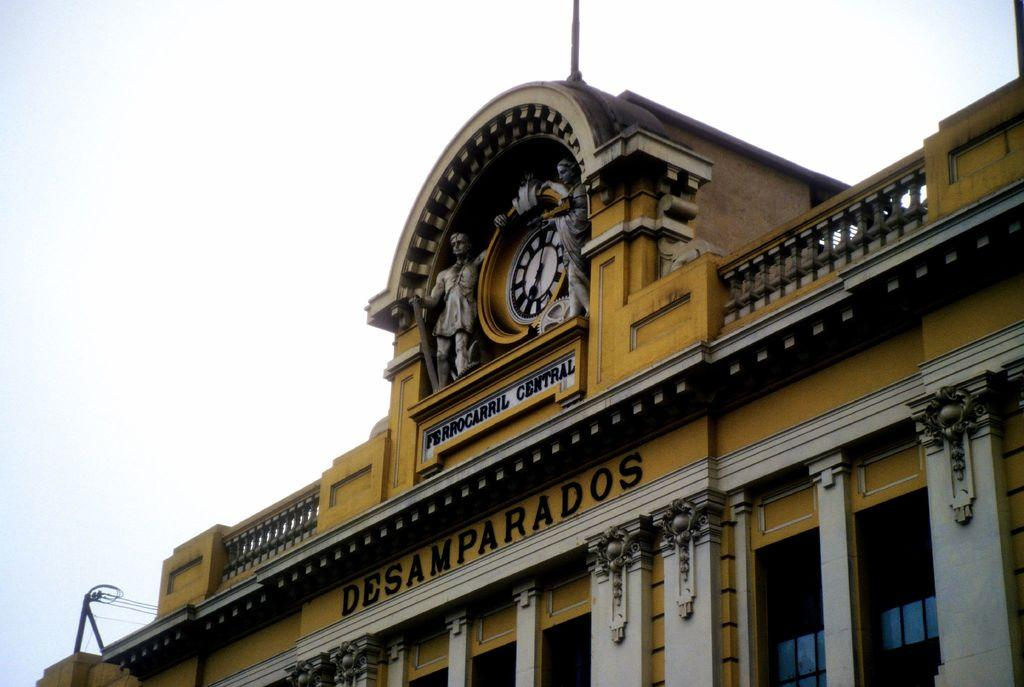Provide a one-sentence caption for the provided image. A clock at the top of the Ferrocarril Central Desamparados building. 